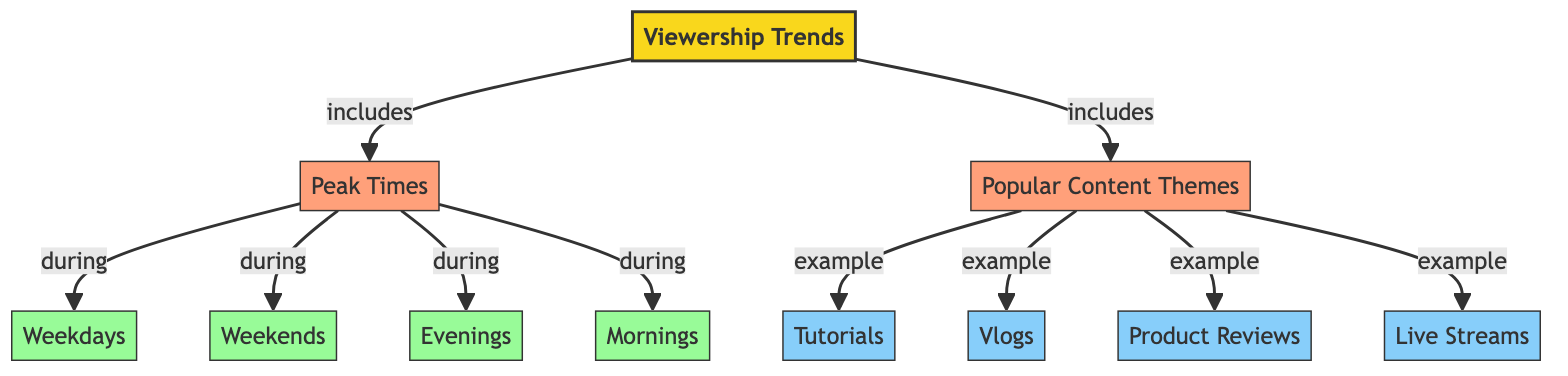What are the two main categories included in viewership trends? The diagram shows that the two main categories included in viewership trends are "Peak Times" and "Popular Content Themes."
Answer: Peak Times, Popular Content Themes How many time periods are identified in the "Peak Times" section? In the "Peak Times" section, there are four identified time periods: Weekdays, Weekends, Evenings, and Mornings.
Answer: Four Which content theme is listed as an example in the "Popular Content Themes" section? The diagram displays four content themes, and one of the examples listed is "Tutorials."
Answer: Tutorials Which time period is associated with "Peak Times" that occurs on Saturday and Sunday? The time period associated with "Peak Times" that occurs on Saturday and Sunday is "Weekends."
Answer: Weekends What is the relationship between "Viewership Trends" and "Peak Times"? The relationship is expressed as "Viewership Trends includes Peak Times," showing that Peak Times is a category under the broader concept of Viewership Trends.
Answer: includes How many content themes are mentioned in the "Popular Content Themes"? The diagram shows there are four content themes mentioned: Tutorials, Vlogs, Product Reviews, and Live Streams.
Answer: Four Which morning time period is identified in the "Peak Times"? The morning time period identified in the "Peak Times" section is "Mornings."
Answer: Mornings Which is an inclusion of the viewership trends diagram that relates to time? "Peak Times" is an inclusion of the viewership trends diagram that specifically relates to time.
Answer: Peak Times 